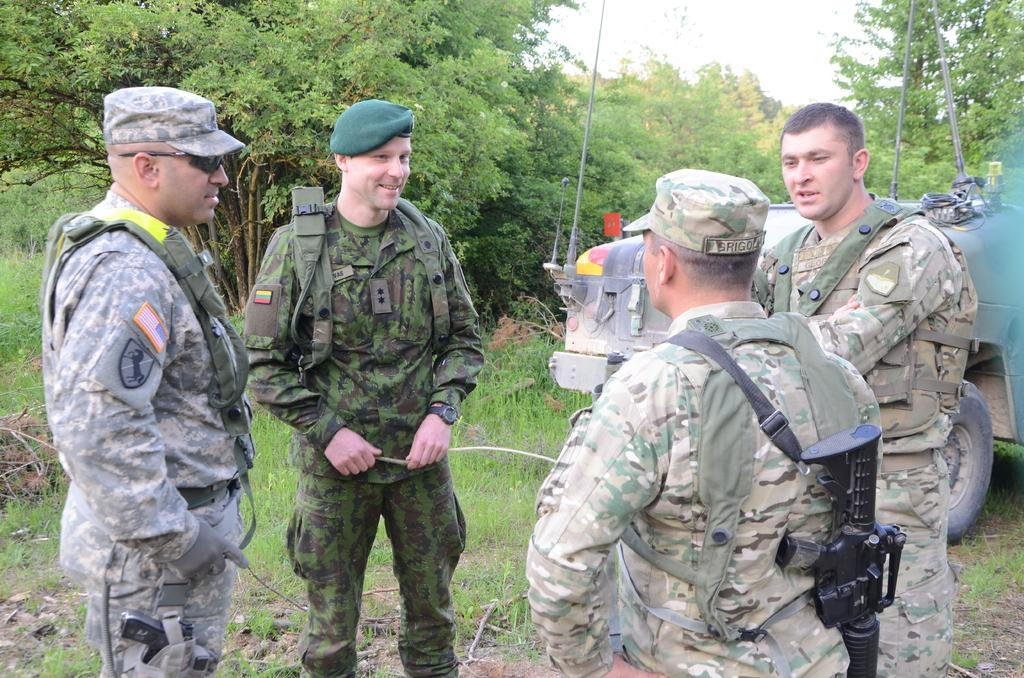How many Army men are present in the image? There are 4 Army men in the image. What are the Army men doing in the image? The Army men are standing and speaking. What are the Army men wearing in the image? The Army men are wearing army dresses, caps, and have weapons. What can be seen on the right side of the image? There is a vehicle on the right side of the image. What is visible at the back side of the image? There are trees at the back side of the image. What type of sidewalk can be seen in the image? There is no sidewalk present in the image. 